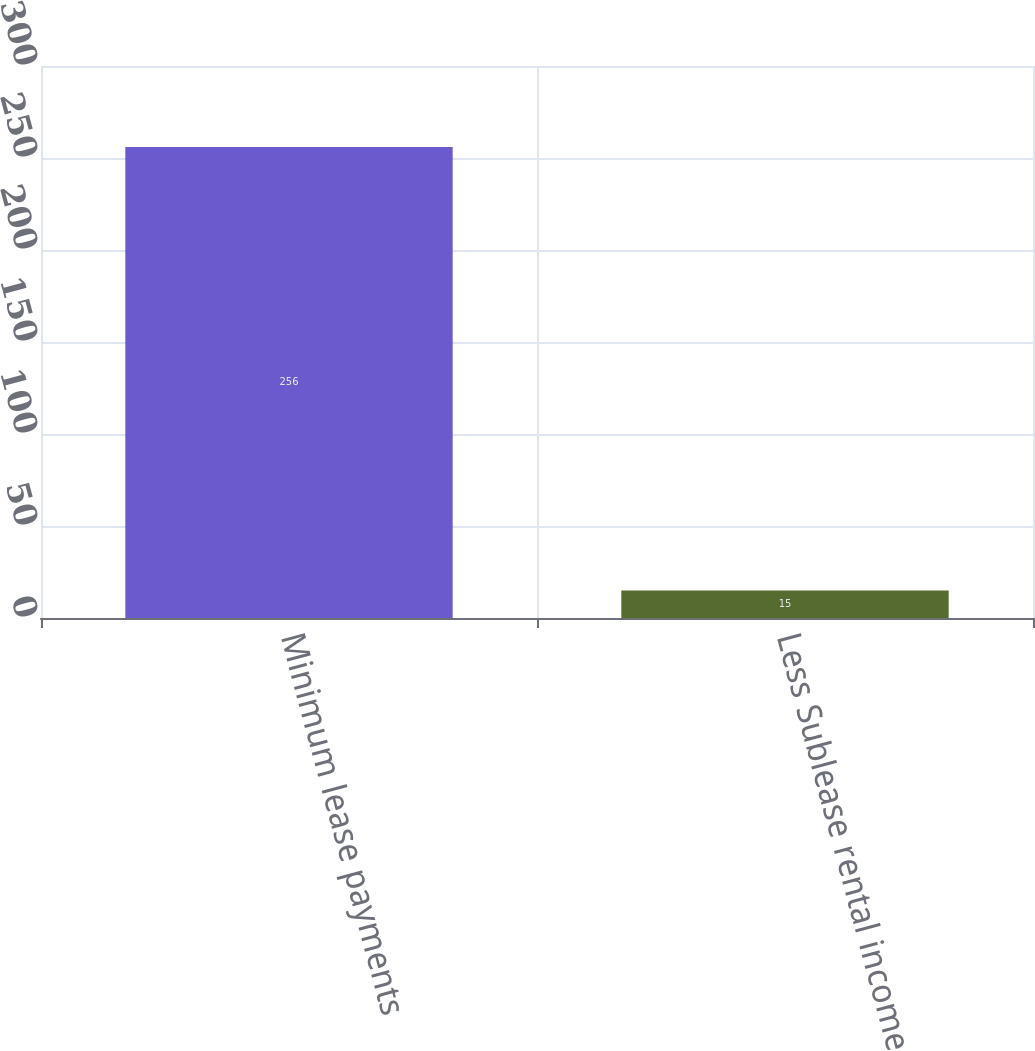Convert chart to OTSL. <chart><loc_0><loc_0><loc_500><loc_500><bar_chart><fcel>Minimum lease payments<fcel>Less Sublease rental income<nl><fcel>256<fcel>15<nl></chart> 